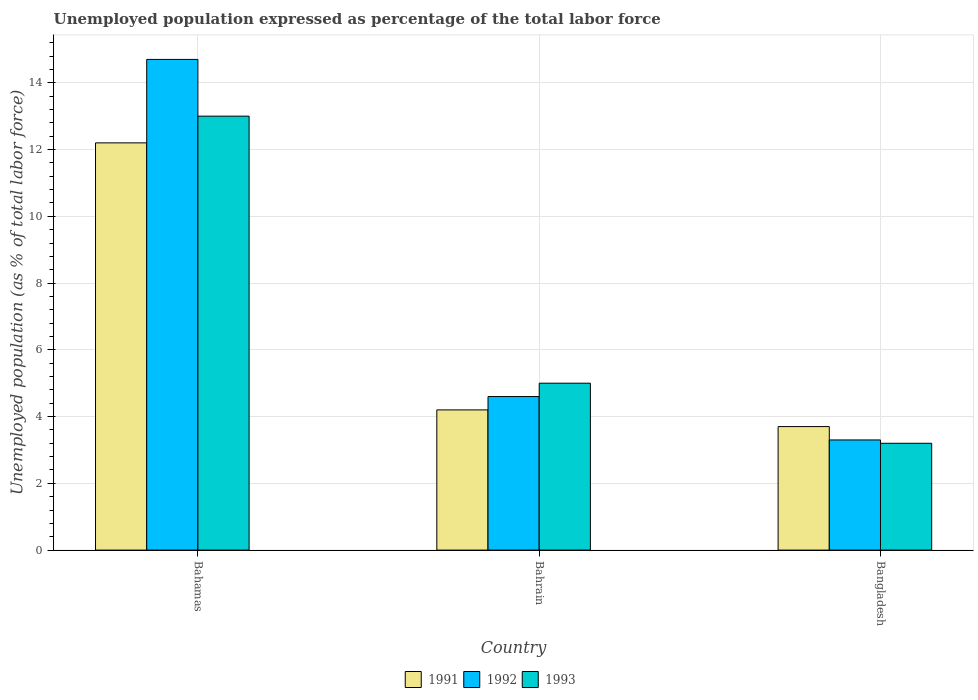How many groups of bars are there?
Provide a succinct answer. 3. Are the number of bars on each tick of the X-axis equal?
Provide a succinct answer. Yes. How many bars are there on the 2nd tick from the left?
Offer a very short reply. 3. What is the label of the 1st group of bars from the left?
Make the answer very short. Bahamas. In how many cases, is the number of bars for a given country not equal to the number of legend labels?
Make the answer very short. 0. What is the unemployment in in 1992 in Bahamas?
Give a very brief answer. 14.7. Across all countries, what is the maximum unemployment in in 1992?
Provide a short and direct response. 14.7. Across all countries, what is the minimum unemployment in in 1991?
Provide a short and direct response. 3.7. In which country was the unemployment in in 1991 maximum?
Your answer should be compact. Bahamas. What is the total unemployment in in 1992 in the graph?
Your answer should be compact. 22.6. What is the difference between the unemployment in in 1991 in Bahamas and that in Bangladesh?
Offer a terse response. 8.5. What is the difference between the unemployment in in 1993 in Bahamas and the unemployment in in 1991 in Bahrain?
Offer a terse response. 8.8. What is the average unemployment in in 1993 per country?
Your answer should be very brief. 7.07. What is the difference between the unemployment in of/in 1993 and unemployment in of/in 1992 in Bangladesh?
Offer a very short reply. -0.1. What is the ratio of the unemployment in in 1993 in Bahamas to that in Bangladesh?
Your answer should be very brief. 4.06. Is the difference between the unemployment in in 1993 in Bahamas and Bahrain greater than the difference between the unemployment in in 1992 in Bahamas and Bahrain?
Provide a short and direct response. No. What is the difference between the highest and the second highest unemployment in in 1991?
Your answer should be compact. -8.5. What is the difference between the highest and the lowest unemployment in in 1992?
Your answer should be compact. 11.4. Is the sum of the unemployment in in 1992 in Bahrain and Bangladesh greater than the maximum unemployment in in 1993 across all countries?
Your response must be concise. No. What does the 2nd bar from the left in Bangladesh represents?
Provide a succinct answer. 1992. What does the 1st bar from the right in Bahrain represents?
Offer a terse response. 1993. What is the difference between two consecutive major ticks on the Y-axis?
Offer a very short reply. 2. Are the values on the major ticks of Y-axis written in scientific E-notation?
Provide a succinct answer. No. How many legend labels are there?
Your answer should be compact. 3. How are the legend labels stacked?
Your answer should be compact. Horizontal. What is the title of the graph?
Provide a short and direct response. Unemployed population expressed as percentage of the total labor force. Does "2001" appear as one of the legend labels in the graph?
Your answer should be very brief. No. What is the label or title of the Y-axis?
Keep it short and to the point. Unemployed population (as % of total labor force). What is the Unemployed population (as % of total labor force) of 1991 in Bahamas?
Provide a succinct answer. 12.2. What is the Unemployed population (as % of total labor force) of 1992 in Bahamas?
Your answer should be very brief. 14.7. What is the Unemployed population (as % of total labor force) of 1993 in Bahamas?
Your answer should be very brief. 13. What is the Unemployed population (as % of total labor force) of 1991 in Bahrain?
Offer a very short reply. 4.2. What is the Unemployed population (as % of total labor force) of 1992 in Bahrain?
Ensure brevity in your answer.  4.6. What is the Unemployed population (as % of total labor force) in 1993 in Bahrain?
Offer a terse response. 5. What is the Unemployed population (as % of total labor force) in 1991 in Bangladesh?
Offer a very short reply. 3.7. What is the Unemployed population (as % of total labor force) of 1992 in Bangladesh?
Provide a short and direct response. 3.3. What is the Unemployed population (as % of total labor force) in 1993 in Bangladesh?
Keep it short and to the point. 3.2. Across all countries, what is the maximum Unemployed population (as % of total labor force) in 1991?
Your answer should be very brief. 12.2. Across all countries, what is the maximum Unemployed population (as % of total labor force) in 1992?
Make the answer very short. 14.7. Across all countries, what is the maximum Unemployed population (as % of total labor force) of 1993?
Make the answer very short. 13. Across all countries, what is the minimum Unemployed population (as % of total labor force) of 1991?
Offer a very short reply. 3.7. Across all countries, what is the minimum Unemployed population (as % of total labor force) in 1992?
Keep it short and to the point. 3.3. Across all countries, what is the minimum Unemployed population (as % of total labor force) of 1993?
Offer a terse response. 3.2. What is the total Unemployed population (as % of total labor force) in 1991 in the graph?
Provide a short and direct response. 20.1. What is the total Unemployed population (as % of total labor force) of 1992 in the graph?
Offer a very short reply. 22.6. What is the total Unemployed population (as % of total labor force) of 1993 in the graph?
Make the answer very short. 21.2. What is the difference between the Unemployed population (as % of total labor force) in 1991 in Bahamas and that in Bahrain?
Make the answer very short. 8. What is the difference between the Unemployed population (as % of total labor force) in 1992 in Bahamas and that in Bahrain?
Offer a terse response. 10.1. What is the difference between the Unemployed population (as % of total labor force) in 1993 in Bahamas and that in Bahrain?
Your answer should be very brief. 8. What is the difference between the Unemployed population (as % of total labor force) in 1991 in Bahamas and that in Bangladesh?
Offer a very short reply. 8.5. What is the difference between the Unemployed population (as % of total labor force) in 1992 in Bahrain and that in Bangladesh?
Keep it short and to the point. 1.3. What is the difference between the Unemployed population (as % of total labor force) in 1993 in Bahrain and that in Bangladesh?
Give a very brief answer. 1.8. What is the difference between the Unemployed population (as % of total labor force) in 1991 in Bahamas and the Unemployed population (as % of total labor force) in 1993 in Bahrain?
Offer a very short reply. 7.2. What is the difference between the Unemployed population (as % of total labor force) in 1991 in Bahamas and the Unemployed population (as % of total labor force) in 1992 in Bangladesh?
Offer a terse response. 8.9. What is the difference between the Unemployed population (as % of total labor force) in 1991 in Bahamas and the Unemployed population (as % of total labor force) in 1993 in Bangladesh?
Your answer should be compact. 9. What is the difference between the Unemployed population (as % of total labor force) of 1992 in Bahrain and the Unemployed population (as % of total labor force) of 1993 in Bangladesh?
Keep it short and to the point. 1.4. What is the average Unemployed population (as % of total labor force) of 1992 per country?
Your answer should be very brief. 7.53. What is the average Unemployed population (as % of total labor force) in 1993 per country?
Your response must be concise. 7.07. What is the difference between the Unemployed population (as % of total labor force) in 1991 and Unemployed population (as % of total labor force) in 1993 in Bahamas?
Give a very brief answer. -0.8. What is the difference between the Unemployed population (as % of total labor force) in 1991 and Unemployed population (as % of total labor force) in 1992 in Bahrain?
Ensure brevity in your answer.  -0.4. What is the difference between the Unemployed population (as % of total labor force) of 1991 and Unemployed population (as % of total labor force) of 1992 in Bangladesh?
Your answer should be very brief. 0.4. What is the difference between the Unemployed population (as % of total labor force) of 1991 and Unemployed population (as % of total labor force) of 1993 in Bangladesh?
Your answer should be compact. 0.5. What is the difference between the Unemployed population (as % of total labor force) in 1992 and Unemployed population (as % of total labor force) in 1993 in Bangladesh?
Offer a terse response. 0.1. What is the ratio of the Unemployed population (as % of total labor force) in 1991 in Bahamas to that in Bahrain?
Make the answer very short. 2.9. What is the ratio of the Unemployed population (as % of total labor force) of 1992 in Bahamas to that in Bahrain?
Ensure brevity in your answer.  3.2. What is the ratio of the Unemployed population (as % of total labor force) in 1991 in Bahamas to that in Bangladesh?
Provide a succinct answer. 3.3. What is the ratio of the Unemployed population (as % of total labor force) of 1992 in Bahamas to that in Bangladesh?
Your response must be concise. 4.45. What is the ratio of the Unemployed population (as % of total labor force) in 1993 in Bahamas to that in Bangladesh?
Offer a very short reply. 4.06. What is the ratio of the Unemployed population (as % of total labor force) in 1991 in Bahrain to that in Bangladesh?
Provide a succinct answer. 1.14. What is the ratio of the Unemployed population (as % of total labor force) of 1992 in Bahrain to that in Bangladesh?
Provide a short and direct response. 1.39. What is the ratio of the Unemployed population (as % of total labor force) of 1993 in Bahrain to that in Bangladesh?
Your answer should be very brief. 1.56. What is the difference between the highest and the lowest Unemployed population (as % of total labor force) in 1991?
Offer a terse response. 8.5. What is the difference between the highest and the lowest Unemployed population (as % of total labor force) of 1992?
Offer a very short reply. 11.4. What is the difference between the highest and the lowest Unemployed population (as % of total labor force) in 1993?
Provide a succinct answer. 9.8. 